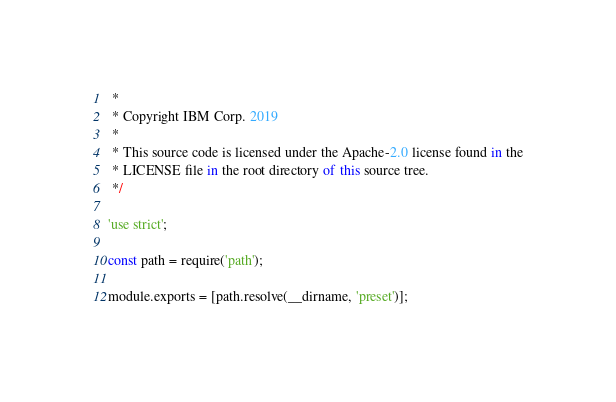<code> <loc_0><loc_0><loc_500><loc_500><_JavaScript_> *
 * Copyright IBM Corp. 2019
 *
 * This source code is licensed under the Apache-2.0 license found in the
 * LICENSE file in the root directory of this source tree.
 */

'use strict';

const path = require('path');

module.exports = [path.resolve(__dirname, 'preset')];
</code> 